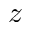<formula> <loc_0><loc_0><loc_500><loc_500>z</formula> 